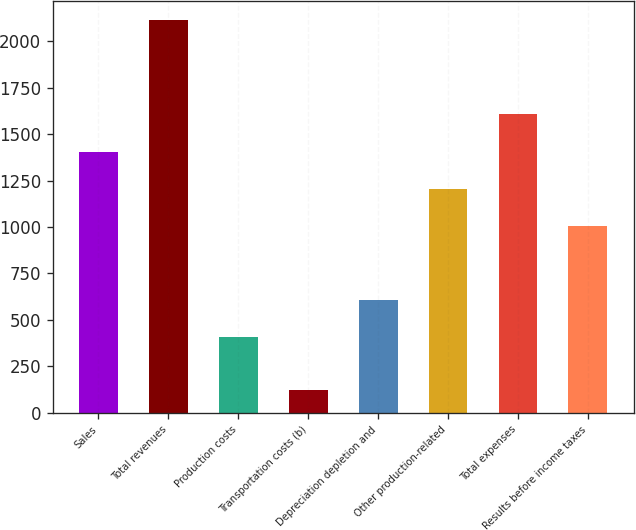Convert chart. <chart><loc_0><loc_0><loc_500><loc_500><bar_chart><fcel>Sales<fcel>Total revenues<fcel>Production costs<fcel>Transportation costs (b)<fcel>Depreciation depletion and<fcel>Other production-related<fcel>Total expenses<fcel>Results before income taxes<nl><fcel>1406.5<fcel>2113<fcel>410<fcel>120<fcel>609.3<fcel>1207.2<fcel>1605.8<fcel>1007.9<nl></chart> 